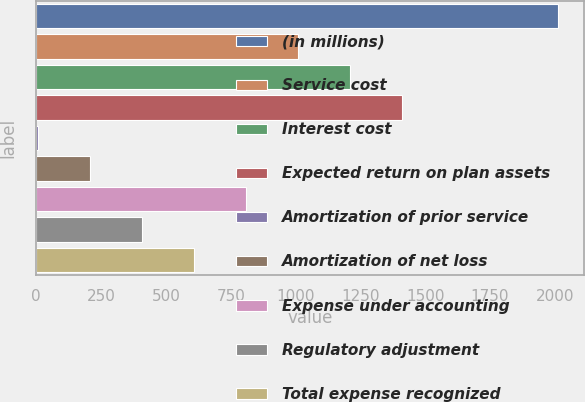<chart> <loc_0><loc_0><loc_500><loc_500><bar_chart><fcel>(in millions)<fcel>Service cost<fcel>Interest cost<fcel>Expected return on plan assets<fcel>Amortization of prior service<fcel>Amortization of net loss<fcel>Expense under accounting<fcel>Regulatory adjustment<fcel>Total expense recognized<nl><fcel>2011<fcel>1009<fcel>1209.4<fcel>1409.8<fcel>7<fcel>207.4<fcel>808.6<fcel>407.8<fcel>608.2<nl></chart> 